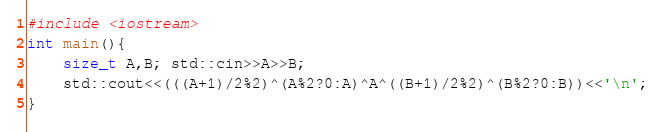<code> <loc_0><loc_0><loc_500><loc_500><_C++_>#include <iostream>
int main(){
    size_t A,B; std::cin>>A>>B;
    std::cout<<(((A+1)/2%2)^(A%2?0:A)^A^((B+1)/2%2)^(B%2?0:B))<<'\n';
}</code> 